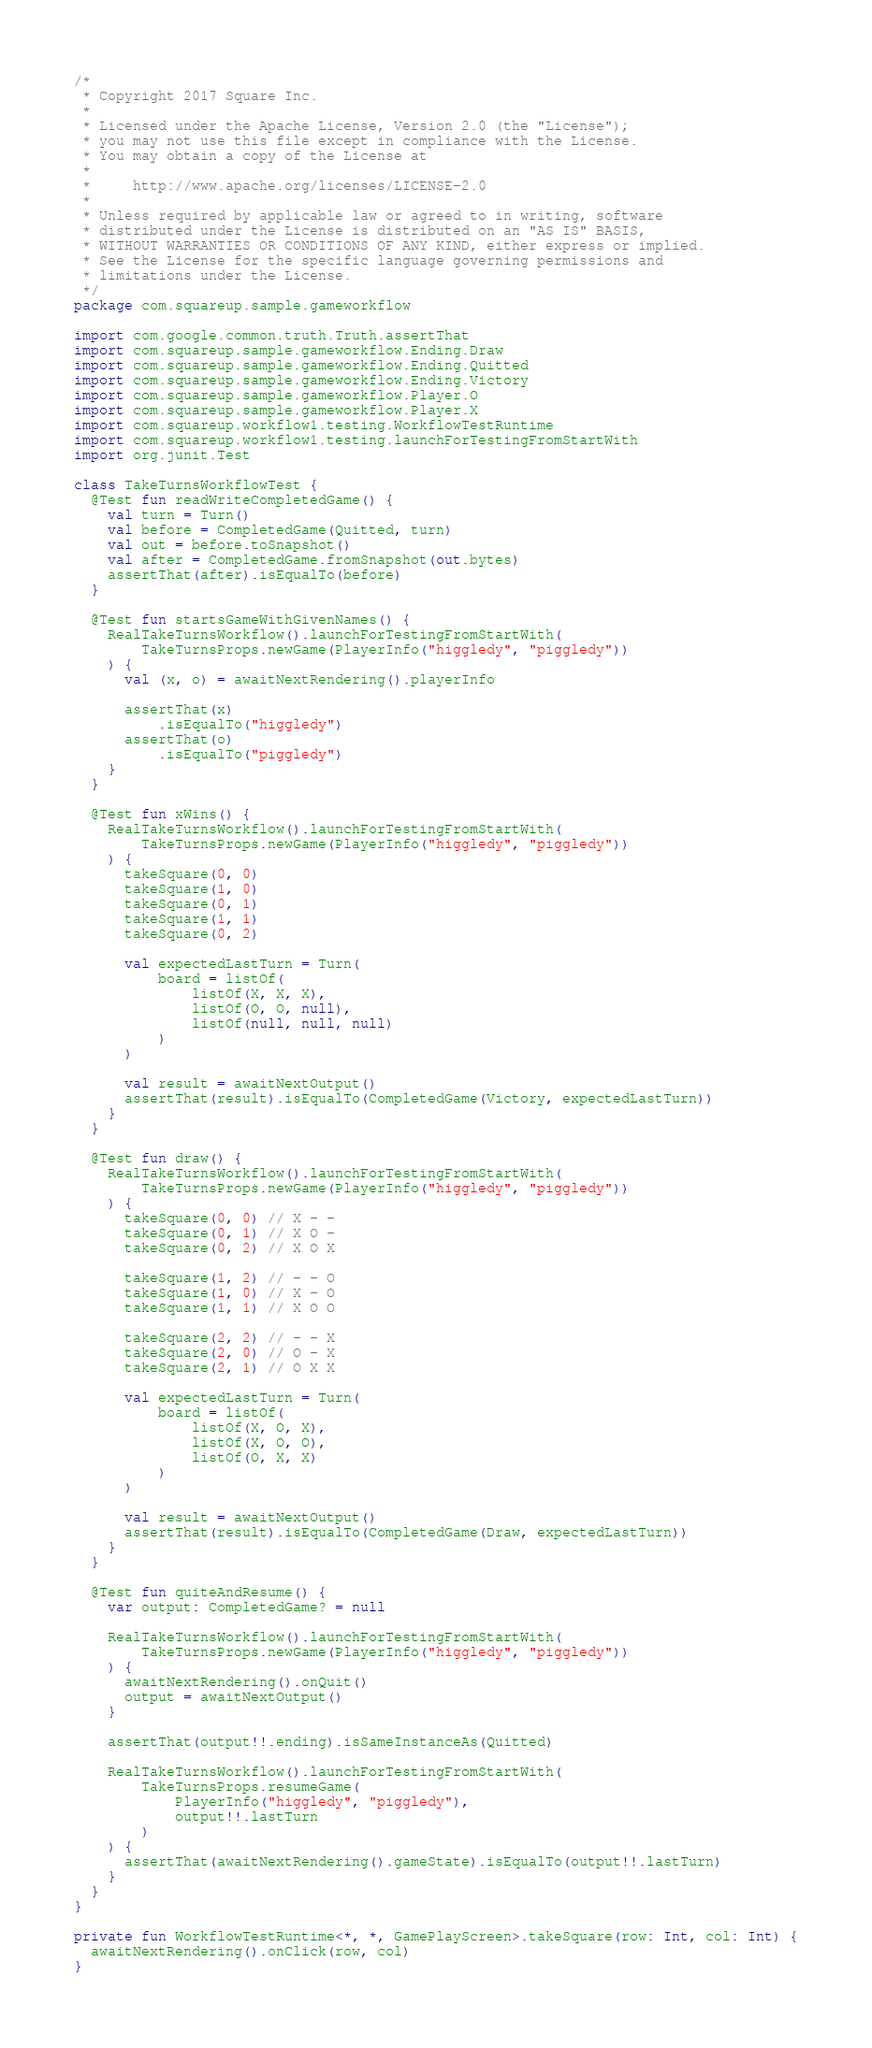Convert code to text. <code><loc_0><loc_0><loc_500><loc_500><_Kotlin_>/*
 * Copyright 2017 Square Inc.
 *
 * Licensed under the Apache License, Version 2.0 (the "License");
 * you may not use this file except in compliance with the License.
 * You may obtain a copy of the License at
 *
 *     http://www.apache.org/licenses/LICENSE-2.0
 *
 * Unless required by applicable law or agreed to in writing, software
 * distributed under the License is distributed on an "AS IS" BASIS,
 * WITHOUT WARRANTIES OR CONDITIONS OF ANY KIND, either express or implied.
 * See the License for the specific language governing permissions and
 * limitations under the License.
 */
package com.squareup.sample.gameworkflow

import com.google.common.truth.Truth.assertThat
import com.squareup.sample.gameworkflow.Ending.Draw
import com.squareup.sample.gameworkflow.Ending.Quitted
import com.squareup.sample.gameworkflow.Ending.Victory
import com.squareup.sample.gameworkflow.Player.O
import com.squareup.sample.gameworkflow.Player.X
import com.squareup.workflow1.testing.WorkflowTestRuntime
import com.squareup.workflow1.testing.launchForTestingFromStartWith
import org.junit.Test

class TakeTurnsWorkflowTest {
  @Test fun readWriteCompletedGame() {
    val turn = Turn()
    val before = CompletedGame(Quitted, turn)
    val out = before.toSnapshot()
    val after = CompletedGame.fromSnapshot(out.bytes)
    assertThat(after).isEqualTo(before)
  }

  @Test fun startsGameWithGivenNames() {
    RealTakeTurnsWorkflow().launchForTestingFromStartWith(
        TakeTurnsProps.newGame(PlayerInfo("higgledy", "piggledy"))
    ) {
      val (x, o) = awaitNextRendering().playerInfo

      assertThat(x)
          .isEqualTo("higgledy")
      assertThat(o)
          .isEqualTo("piggledy")
    }
  }

  @Test fun xWins() {
    RealTakeTurnsWorkflow().launchForTestingFromStartWith(
        TakeTurnsProps.newGame(PlayerInfo("higgledy", "piggledy"))
    ) {
      takeSquare(0, 0)
      takeSquare(1, 0)
      takeSquare(0, 1)
      takeSquare(1, 1)
      takeSquare(0, 2)

      val expectedLastTurn = Turn(
          board = listOf(
              listOf(X, X, X),
              listOf(O, O, null),
              listOf(null, null, null)
          )
      )

      val result = awaitNextOutput()
      assertThat(result).isEqualTo(CompletedGame(Victory, expectedLastTurn))
    }
  }

  @Test fun draw() {
    RealTakeTurnsWorkflow().launchForTestingFromStartWith(
        TakeTurnsProps.newGame(PlayerInfo("higgledy", "piggledy"))
    ) {
      takeSquare(0, 0) // X - -
      takeSquare(0, 1) // X O -
      takeSquare(0, 2) // X O X

      takeSquare(1, 2) // - - O
      takeSquare(1, 0) // X - O
      takeSquare(1, 1) // X O O

      takeSquare(2, 2) // - - X
      takeSquare(2, 0) // O - X
      takeSquare(2, 1) // O X X

      val expectedLastTurn = Turn(
          board = listOf(
              listOf(X, O, X),
              listOf(X, O, O),
              listOf(O, X, X)
          )
      )

      val result = awaitNextOutput()
      assertThat(result).isEqualTo(CompletedGame(Draw, expectedLastTurn))
    }
  }

  @Test fun quiteAndResume() {
    var output: CompletedGame? = null

    RealTakeTurnsWorkflow().launchForTestingFromStartWith(
        TakeTurnsProps.newGame(PlayerInfo("higgledy", "piggledy"))
    ) {
      awaitNextRendering().onQuit()
      output = awaitNextOutput()
    }

    assertThat(output!!.ending).isSameInstanceAs(Quitted)

    RealTakeTurnsWorkflow().launchForTestingFromStartWith(
        TakeTurnsProps.resumeGame(
            PlayerInfo("higgledy", "piggledy"),
            output!!.lastTurn
        )
    ) {
      assertThat(awaitNextRendering().gameState).isEqualTo(output!!.lastTurn)
    }
  }
}

private fun WorkflowTestRuntime<*, *, GamePlayScreen>.takeSquare(row: Int, col: Int) {
  awaitNextRendering().onClick(row, col)
}
</code> 